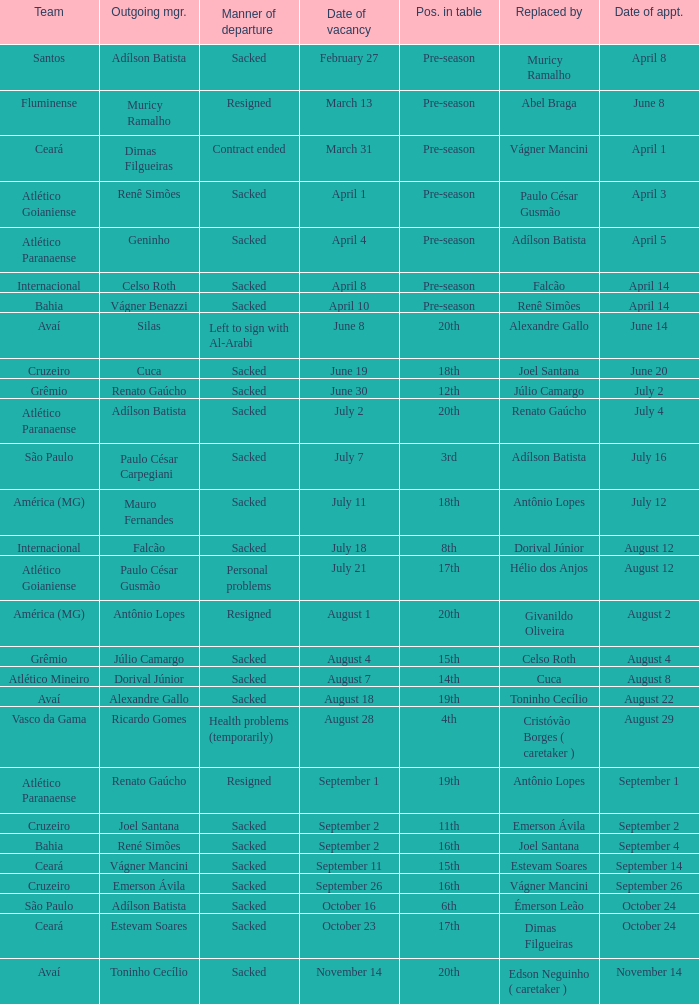Who was the new Santos manager? Muricy Ramalho. 